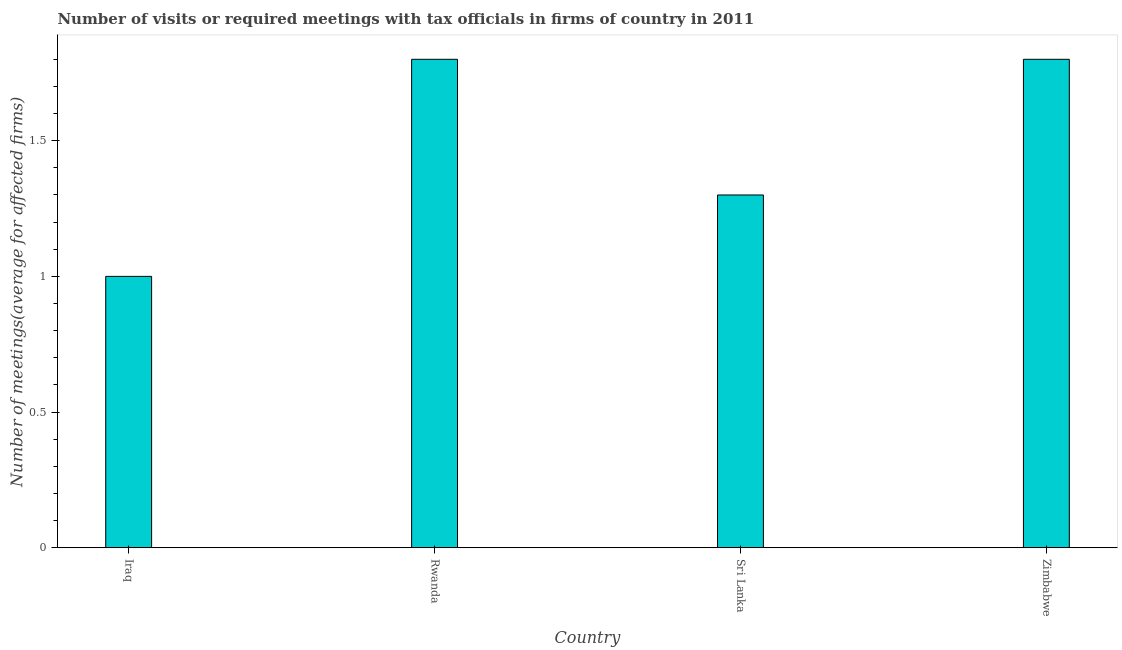Does the graph contain grids?
Make the answer very short. No. What is the title of the graph?
Offer a very short reply. Number of visits or required meetings with tax officials in firms of country in 2011. What is the label or title of the X-axis?
Your answer should be very brief. Country. What is the label or title of the Y-axis?
Ensure brevity in your answer.  Number of meetings(average for affected firms). Across all countries, what is the maximum number of required meetings with tax officials?
Provide a short and direct response. 1.8. Across all countries, what is the minimum number of required meetings with tax officials?
Give a very brief answer. 1. In which country was the number of required meetings with tax officials maximum?
Keep it short and to the point. Rwanda. In which country was the number of required meetings with tax officials minimum?
Your response must be concise. Iraq. What is the sum of the number of required meetings with tax officials?
Make the answer very short. 5.9. What is the average number of required meetings with tax officials per country?
Provide a short and direct response. 1.48. What is the median number of required meetings with tax officials?
Offer a terse response. 1.55. In how many countries, is the number of required meetings with tax officials greater than 0.6 ?
Offer a very short reply. 4. What is the ratio of the number of required meetings with tax officials in Iraq to that in Sri Lanka?
Your answer should be very brief. 0.77. Is the difference between the number of required meetings with tax officials in Rwanda and Sri Lanka greater than the difference between any two countries?
Your answer should be very brief. No. What is the difference between the highest and the second highest number of required meetings with tax officials?
Your answer should be very brief. 0. Are all the bars in the graph horizontal?
Give a very brief answer. No. Are the values on the major ticks of Y-axis written in scientific E-notation?
Keep it short and to the point. No. What is the difference between the Number of meetings(average for affected firms) in Iraq and Rwanda?
Your response must be concise. -0.8. What is the difference between the Number of meetings(average for affected firms) in Iraq and Sri Lanka?
Your response must be concise. -0.3. What is the difference between the Number of meetings(average for affected firms) in Iraq and Zimbabwe?
Offer a terse response. -0.8. What is the difference between the Number of meetings(average for affected firms) in Rwanda and Sri Lanka?
Provide a succinct answer. 0.5. What is the difference between the Number of meetings(average for affected firms) in Rwanda and Zimbabwe?
Offer a terse response. 0. What is the ratio of the Number of meetings(average for affected firms) in Iraq to that in Rwanda?
Make the answer very short. 0.56. What is the ratio of the Number of meetings(average for affected firms) in Iraq to that in Sri Lanka?
Your response must be concise. 0.77. What is the ratio of the Number of meetings(average for affected firms) in Iraq to that in Zimbabwe?
Provide a short and direct response. 0.56. What is the ratio of the Number of meetings(average for affected firms) in Rwanda to that in Sri Lanka?
Provide a short and direct response. 1.39. What is the ratio of the Number of meetings(average for affected firms) in Rwanda to that in Zimbabwe?
Your response must be concise. 1. What is the ratio of the Number of meetings(average for affected firms) in Sri Lanka to that in Zimbabwe?
Offer a very short reply. 0.72. 